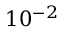Convert formula to latex. <formula><loc_0><loc_0><loc_500><loc_500>1 0 ^ { - 2 }</formula> 